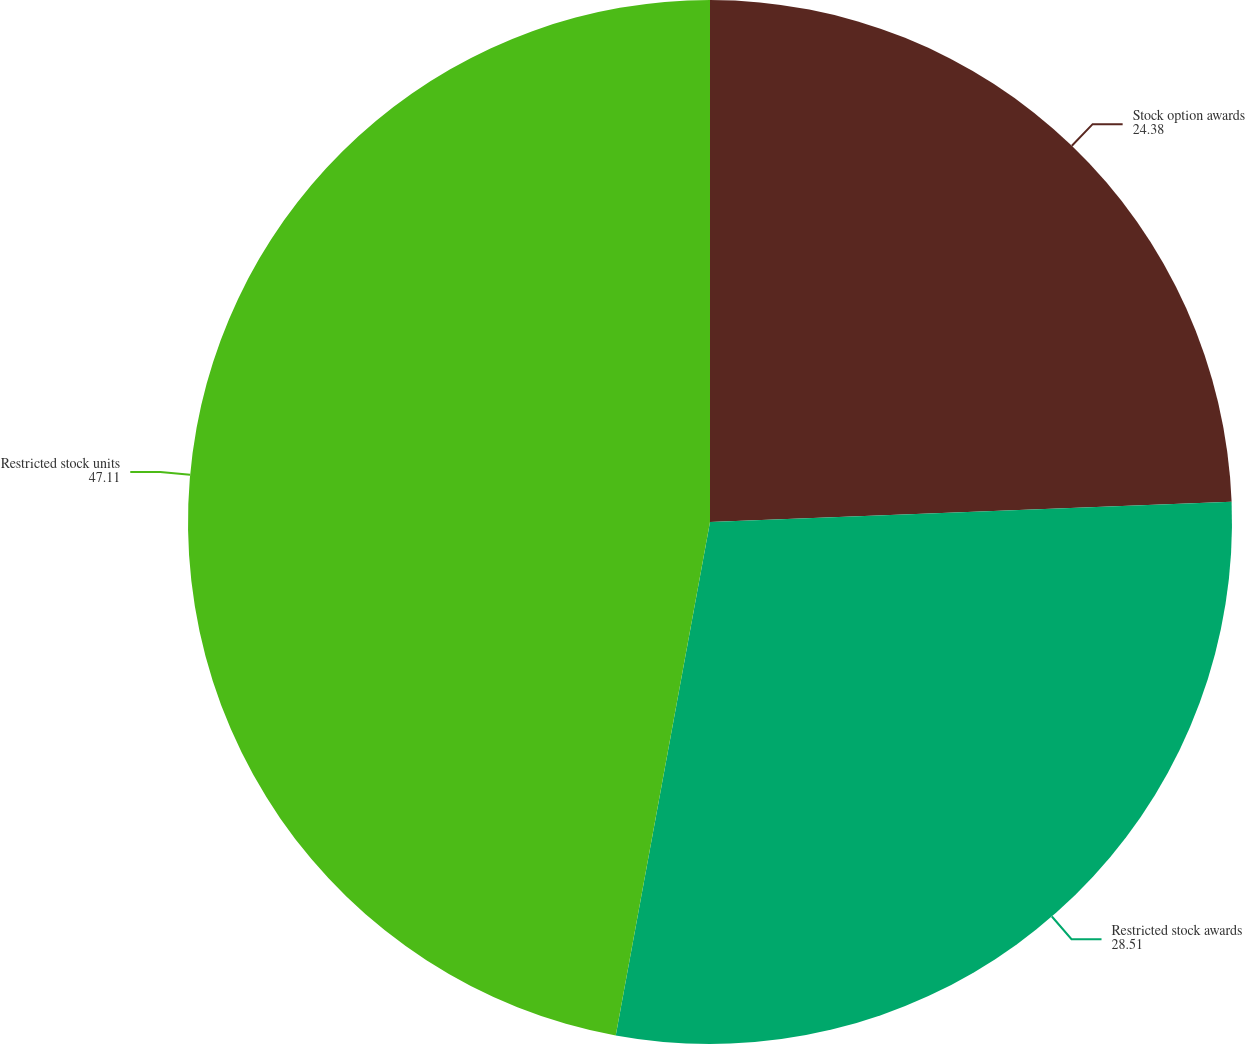Convert chart to OTSL. <chart><loc_0><loc_0><loc_500><loc_500><pie_chart><fcel>Stock option awards<fcel>Restricted stock awards<fcel>Restricted stock units<nl><fcel>24.38%<fcel>28.51%<fcel>47.11%<nl></chart> 